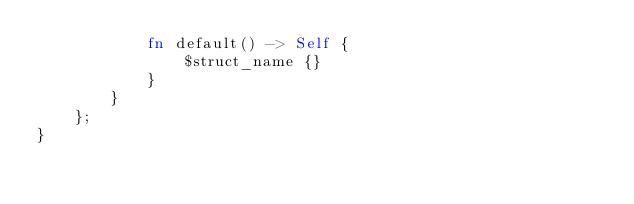<code> <loc_0><loc_0><loc_500><loc_500><_Rust_>            fn default() -> Self {
                $struct_name {}
            }
        }
    };
}
</code> 